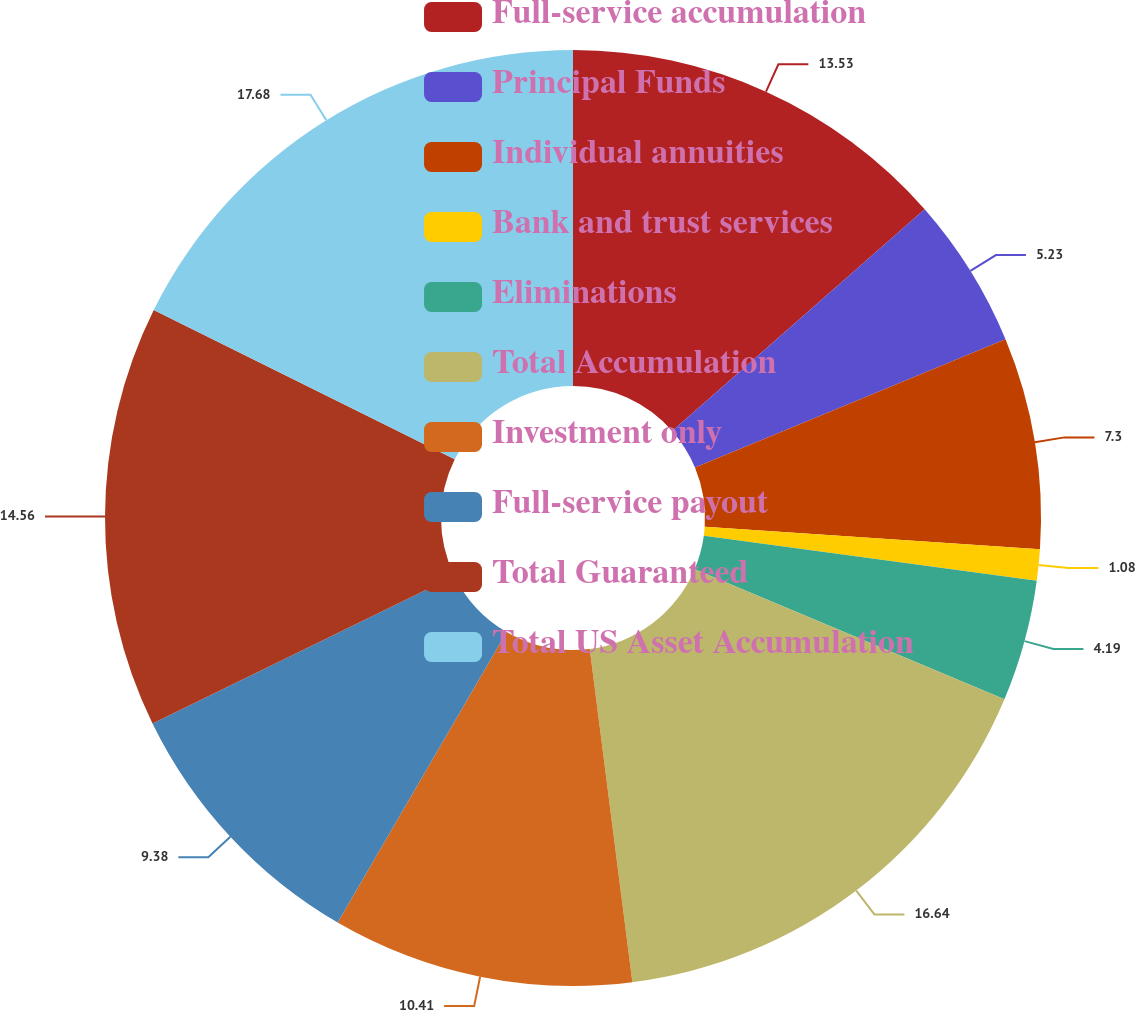Convert chart to OTSL. <chart><loc_0><loc_0><loc_500><loc_500><pie_chart><fcel>Full-service accumulation<fcel>Principal Funds<fcel>Individual annuities<fcel>Bank and trust services<fcel>Eliminations<fcel>Total Accumulation<fcel>Investment only<fcel>Full-service payout<fcel>Total Guaranteed<fcel>Total US Asset Accumulation<nl><fcel>13.53%<fcel>5.23%<fcel>7.3%<fcel>1.08%<fcel>4.19%<fcel>16.64%<fcel>10.41%<fcel>9.38%<fcel>14.56%<fcel>17.67%<nl></chart> 